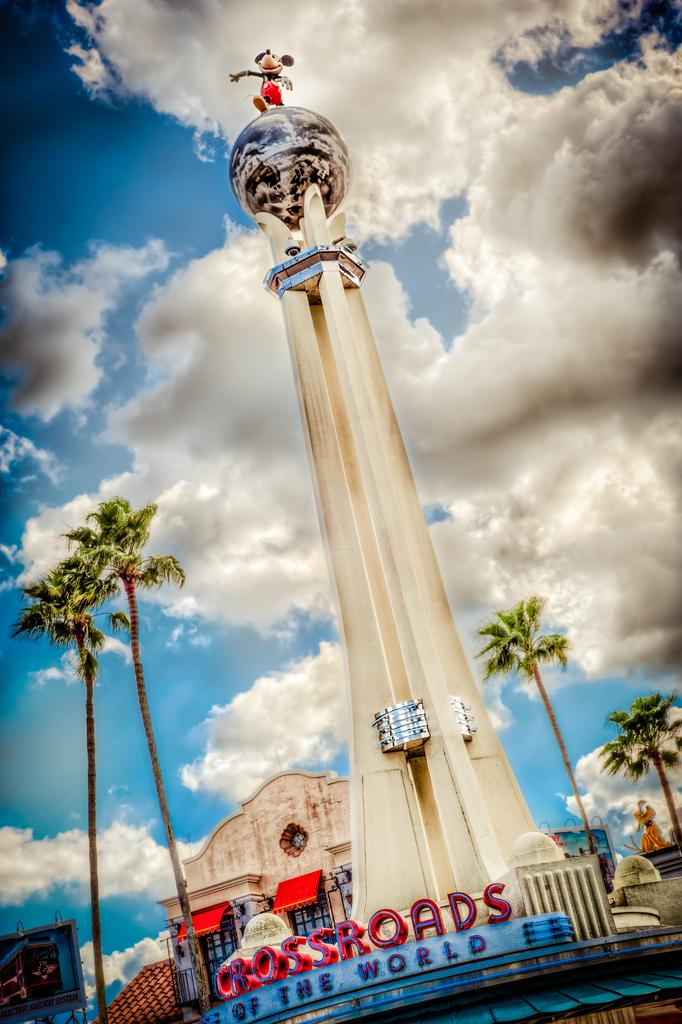What is the main structure in the center of the image? There is a pillar in the center of the image. What can be seen on the left side of the image? There are trees on the left side of the image. What is visible in the background of the image? Trees, buildings, the sky, and clouds are visible in the background of the image. What flavor of books can be seen on the tramp in the image? There is no tramp or books present in the image. 